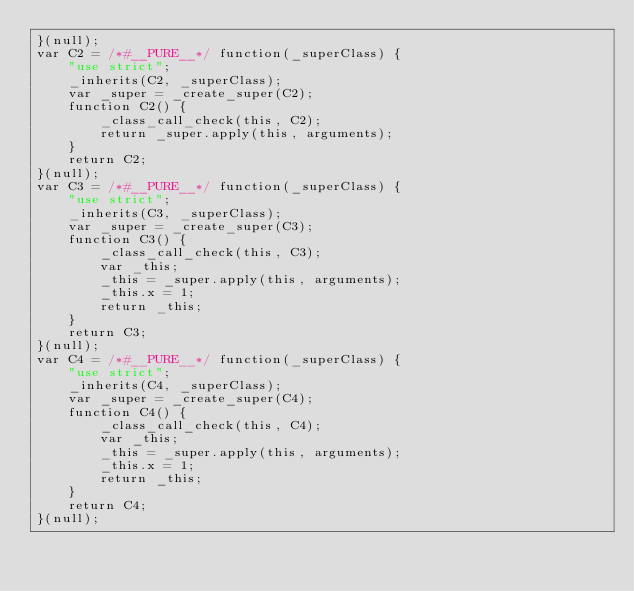Convert code to text. <code><loc_0><loc_0><loc_500><loc_500><_JavaScript_>}(null);
var C2 = /*#__PURE__*/ function(_superClass) {
    "use strict";
    _inherits(C2, _superClass);
    var _super = _create_super(C2);
    function C2() {
        _class_call_check(this, C2);
        return _super.apply(this, arguments);
    }
    return C2;
}(null);
var C3 = /*#__PURE__*/ function(_superClass) {
    "use strict";
    _inherits(C3, _superClass);
    var _super = _create_super(C3);
    function C3() {
        _class_call_check(this, C3);
        var _this;
        _this = _super.apply(this, arguments);
        _this.x = 1;
        return _this;
    }
    return C3;
}(null);
var C4 = /*#__PURE__*/ function(_superClass) {
    "use strict";
    _inherits(C4, _superClass);
    var _super = _create_super(C4);
    function C4() {
        _class_call_check(this, C4);
        var _this;
        _this = _super.apply(this, arguments);
        _this.x = 1;
        return _this;
    }
    return C4;
}(null);
</code> 